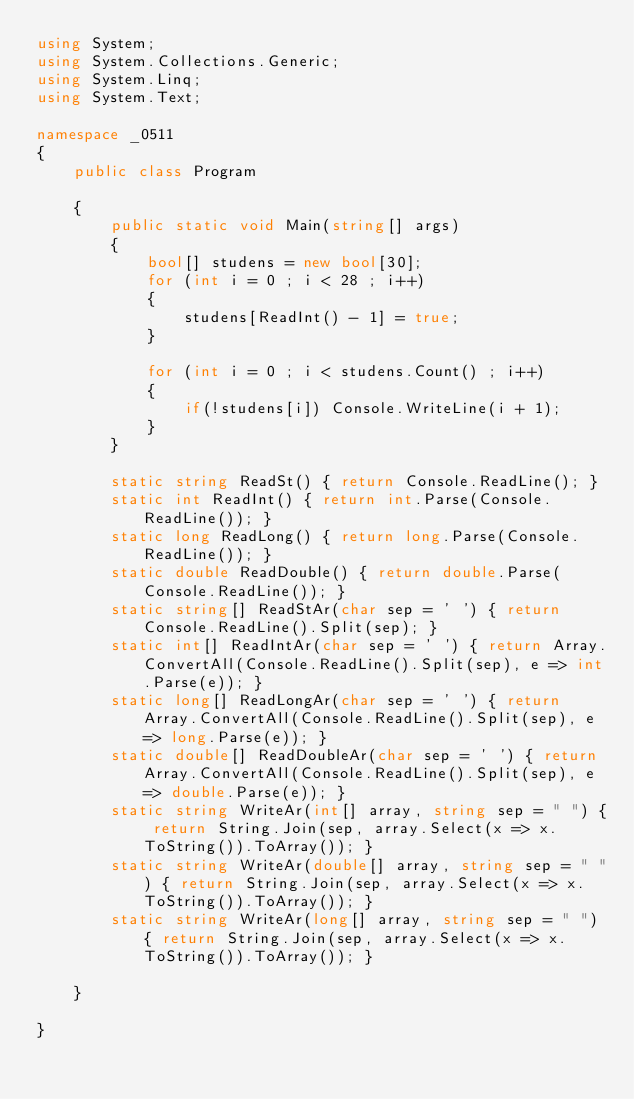Convert code to text. <code><loc_0><loc_0><loc_500><loc_500><_C#_>using System;
using System.Collections.Generic;
using System.Linq;
using System.Text;

namespace _0511
{
    public class Program

    {
        public static void Main(string[] args)
        {
            bool[] studens = new bool[30];
            for (int i = 0 ; i < 28 ; i++)
            {
                studens[ReadInt() - 1] = true;
            }

            for (int i = 0 ; i < studens.Count() ; i++)
            {
                if(!studens[i]) Console.WriteLine(i + 1);
            }            
        }

        static string ReadSt() { return Console.ReadLine(); }
        static int ReadInt() { return int.Parse(Console.ReadLine()); }
        static long ReadLong() { return long.Parse(Console.ReadLine()); }
        static double ReadDouble() { return double.Parse(Console.ReadLine()); }
        static string[] ReadStAr(char sep = ' ') { return Console.ReadLine().Split(sep); }
        static int[] ReadIntAr(char sep = ' ') { return Array.ConvertAll(Console.ReadLine().Split(sep), e => int.Parse(e)); }
        static long[] ReadLongAr(char sep = ' ') { return Array.ConvertAll(Console.ReadLine().Split(sep), e => long.Parse(e)); }
        static double[] ReadDoubleAr(char sep = ' ') { return Array.ConvertAll(Console.ReadLine().Split(sep), e => double.Parse(e)); }
        static string WriteAr(int[] array, string sep = " ") { return String.Join(sep, array.Select(x => x.ToString()).ToArray()); }
        static string WriteAr(double[] array, string sep = " ") { return String.Join(sep, array.Select(x => x.ToString()).ToArray()); }
        static string WriteAr(long[] array, string sep = " ") { return String.Join(sep, array.Select(x => x.ToString()).ToArray()); }

    }

}

</code> 